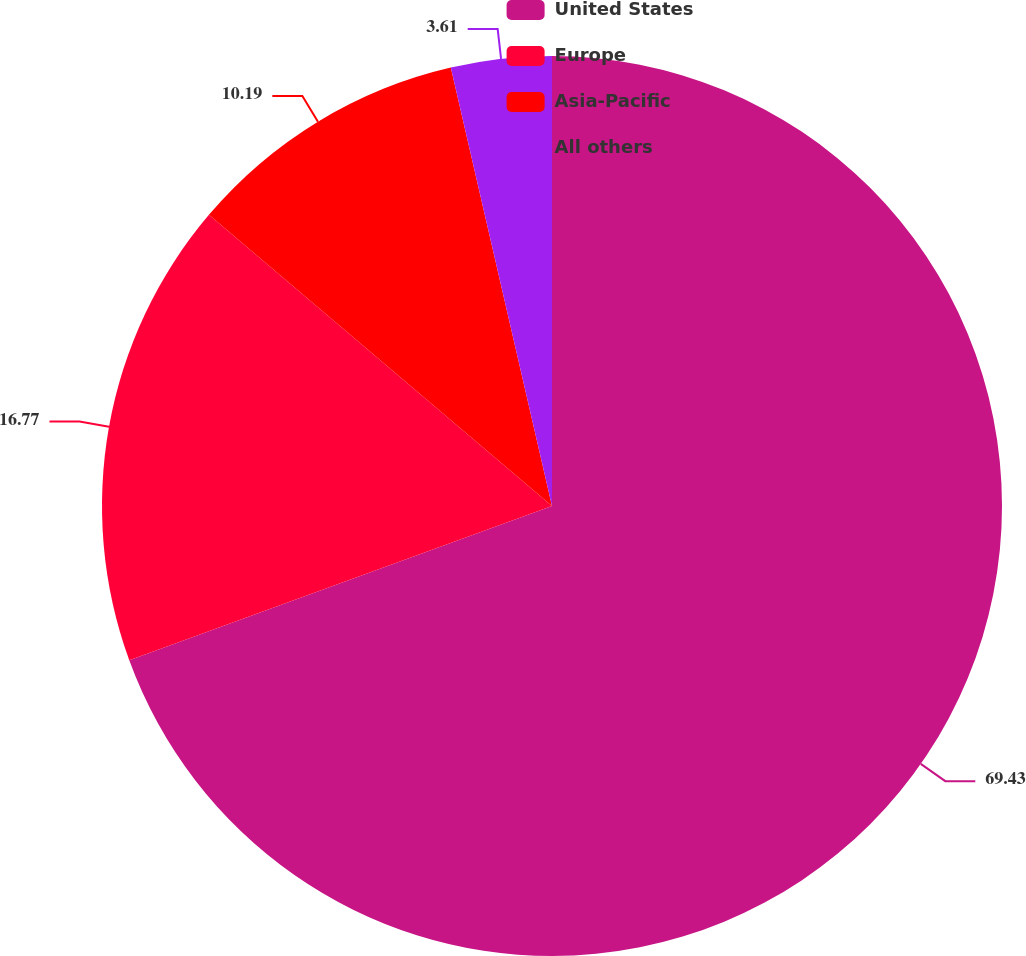Convert chart. <chart><loc_0><loc_0><loc_500><loc_500><pie_chart><fcel>United States<fcel>Europe<fcel>Asia-Pacific<fcel>All others<nl><fcel>69.43%<fcel>16.77%<fcel>10.19%<fcel>3.61%<nl></chart> 